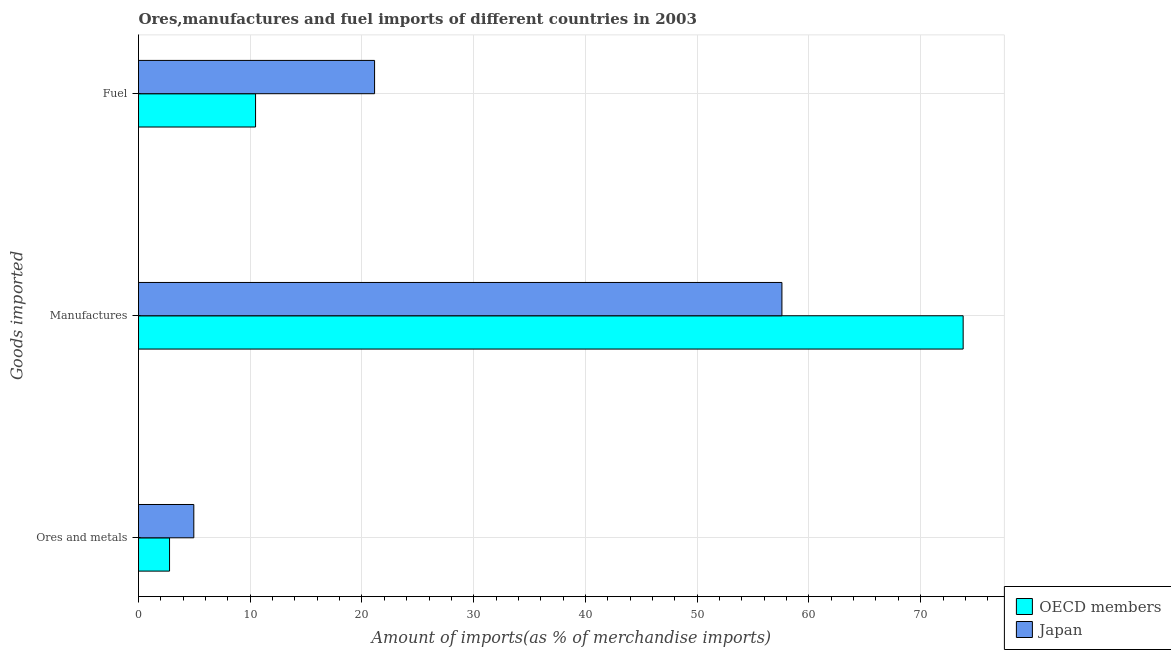How many groups of bars are there?
Make the answer very short. 3. Are the number of bars on each tick of the Y-axis equal?
Offer a very short reply. Yes. What is the label of the 2nd group of bars from the top?
Make the answer very short. Manufactures. What is the percentage of ores and metals imports in OECD members?
Keep it short and to the point. 2.78. Across all countries, what is the maximum percentage of manufactures imports?
Provide a succinct answer. 73.8. Across all countries, what is the minimum percentage of fuel imports?
Provide a short and direct response. 10.48. In which country was the percentage of ores and metals imports maximum?
Your answer should be compact. Japan. In which country was the percentage of fuel imports minimum?
Your response must be concise. OECD members. What is the total percentage of ores and metals imports in the graph?
Provide a short and direct response. 7.73. What is the difference between the percentage of fuel imports in Japan and that in OECD members?
Your answer should be very brief. 10.65. What is the difference between the percentage of fuel imports in Japan and the percentage of manufactures imports in OECD members?
Give a very brief answer. -52.67. What is the average percentage of manufactures imports per country?
Keep it short and to the point. 65.69. What is the difference between the percentage of fuel imports and percentage of ores and metals imports in OECD members?
Offer a terse response. 7.7. In how many countries, is the percentage of fuel imports greater than 40 %?
Give a very brief answer. 0. What is the ratio of the percentage of manufactures imports in Japan to that in OECD members?
Give a very brief answer. 0.78. Is the difference between the percentage of fuel imports in Japan and OECD members greater than the difference between the percentage of ores and metals imports in Japan and OECD members?
Offer a very short reply. Yes. What is the difference between the highest and the second highest percentage of ores and metals imports?
Offer a terse response. 2.17. What is the difference between the highest and the lowest percentage of manufactures imports?
Make the answer very short. 16.22. In how many countries, is the percentage of manufactures imports greater than the average percentage of manufactures imports taken over all countries?
Provide a succinct answer. 1. What does the 2nd bar from the top in Manufactures represents?
Keep it short and to the point. OECD members. What does the 1st bar from the bottom in Fuel represents?
Offer a very short reply. OECD members. Is it the case that in every country, the sum of the percentage of ores and metals imports and percentage of manufactures imports is greater than the percentage of fuel imports?
Make the answer very short. Yes. Are all the bars in the graph horizontal?
Offer a very short reply. Yes. What is the difference between two consecutive major ticks on the X-axis?
Your answer should be compact. 10. How are the legend labels stacked?
Your answer should be compact. Vertical. What is the title of the graph?
Make the answer very short. Ores,manufactures and fuel imports of different countries in 2003. What is the label or title of the X-axis?
Keep it short and to the point. Amount of imports(as % of merchandise imports). What is the label or title of the Y-axis?
Provide a succinct answer. Goods imported. What is the Amount of imports(as % of merchandise imports) of OECD members in Ores and metals?
Provide a succinct answer. 2.78. What is the Amount of imports(as % of merchandise imports) in Japan in Ores and metals?
Give a very brief answer. 4.95. What is the Amount of imports(as % of merchandise imports) in OECD members in Manufactures?
Offer a very short reply. 73.8. What is the Amount of imports(as % of merchandise imports) in Japan in Manufactures?
Ensure brevity in your answer.  57.58. What is the Amount of imports(as % of merchandise imports) in OECD members in Fuel?
Your response must be concise. 10.48. What is the Amount of imports(as % of merchandise imports) of Japan in Fuel?
Your response must be concise. 21.13. Across all Goods imported, what is the maximum Amount of imports(as % of merchandise imports) in OECD members?
Keep it short and to the point. 73.8. Across all Goods imported, what is the maximum Amount of imports(as % of merchandise imports) in Japan?
Keep it short and to the point. 57.58. Across all Goods imported, what is the minimum Amount of imports(as % of merchandise imports) of OECD members?
Give a very brief answer. 2.78. Across all Goods imported, what is the minimum Amount of imports(as % of merchandise imports) in Japan?
Give a very brief answer. 4.95. What is the total Amount of imports(as % of merchandise imports) in OECD members in the graph?
Offer a very short reply. 87.05. What is the total Amount of imports(as % of merchandise imports) of Japan in the graph?
Your answer should be compact. 83.66. What is the difference between the Amount of imports(as % of merchandise imports) in OECD members in Ores and metals and that in Manufactures?
Offer a terse response. -71.02. What is the difference between the Amount of imports(as % of merchandise imports) of Japan in Ores and metals and that in Manufactures?
Offer a very short reply. -52.63. What is the difference between the Amount of imports(as % of merchandise imports) in OECD members in Ores and metals and that in Fuel?
Offer a very short reply. -7.7. What is the difference between the Amount of imports(as % of merchandise imports) of Japan in Ores and metals and that in Fuel?
Keep it short and to the point. -16.18. What is the difference between the Amount of imports(as % of merchandise imports) of OECD members in Manufactures and that in Fuel?
Provide a short and direct response. 63.33. What is the difference between the Amount of imports(as % of merchandise imports) of Japan in Manufactures and that in Fuel?
Make the answer very short. 36.45. What is the difference between the Amount of imports(as % of merchandise imports) in OECD members in Ores and metals and the Amount of imports(as % of merchandise imports) in Japan in Manufactures?
Make the answer very short. -54.8. What is the difference between the Amount of imports(as % of merchandise imports) in OECD members in Ores and metals and the Amount of imports(as % of merchandise imports) in Japan in Fuel?
Make the answer very short. -18.35. What is the difference between the Amount of imports(as % of merchandise imports) of OECD members in Manufactures and the Amount of imports(as % of merchandise imports) of Japan in Fuel?
Provide a short and direct response. 52.67. What is the average Amount of imports(as % of merchandise imports) of OECD members per Goods imported?
Keep it short and to the point. 29.02. What is the average Amount of imports(as % of merchandise imports) of Japan per Goods imported?
Provide a short and direct response. 27.89. What is the difference between the Amount of imports(as % of merchandise imports) of OECD members and Amount of imports(as % of merchandise imports) of Japan in Ores and metals?
Your response must be concise. -2.17. What is the difference between the Amount of imports(as % of merchandise imports) in OECD members and Amount of imports(as % of merchandise imports) in Japan in Manufactures?
Give a very brief answer. 16.22. What is the difference between the Amount of imports(as % of merchandise imports) of OECD members and Amount of imports(as % of merchandise imports) of Japan in Fuel?
Your answer should be compact. -10.65. What is the ratio of the Amount of imports(as % of merchandise imports) in OECD members in Ores and metals to that in Manufactures?
Provide a succinct answer. 0.04. What is the ratio of the Amount of imports(as % of merchandise imports) in Japan in Ores and metals to that in Manufactures?
Provide a succinct answer. 0.09. What is the ratio of the Amount of imports(as % of merchandise imports) in OECD members in Ores and metals to that in Fuel?
Your answer should be very brief. 0.27. What is the ratio of the Amount of imports(as % of merchandise imports) in Japan in Ores and metals to that in Fuel?
Offer a very short reply. 0.23. What is the ratio of the Amount of imports(as % of merchandise imports) of OECD members in Manufactures to that in Fuel?
Give a very brief answer. 7.05. What is the ratio of the Amount of imports(as % of merchandise imports) of Japan in Manufactures to that in Fuel?
Keep it short and to the point. 2.73. What is the difference between the highest and the second highest Amount of imports(as % of merchandise imports) of OECD members?
Ensure brevity in your answer.  63.33. What is the difference between the highest and the second highest Amount of imports(as % of merchandise imports) of Japan?
Provide a succinct answer. 36.45. What is the difference between the highest and the lowest Amount of imports(as % of merchandise imports) of OECD members?
Your answer should be very brief. 71.02. What is the difference between the highest and the lowest Amount of imports(as % of merchandise imports) of Japan?
Ensure brevity in your answer.  52.63. 